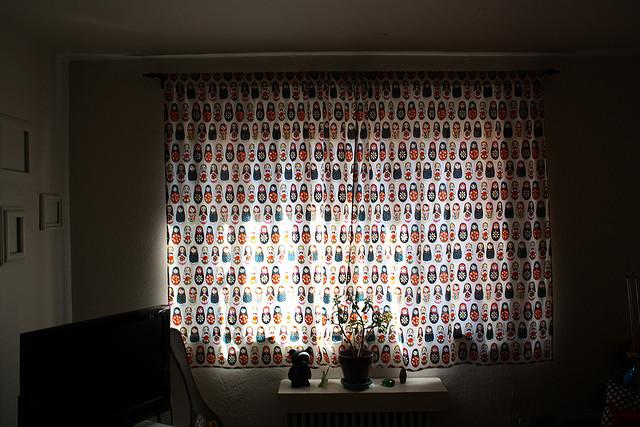What are the walls made of?
Write a very short answer. Plaster. What is hanging in the window?
Write a very short answer. Curtain. Are there curtains on the window?
Answer briefly. Yes. What is covering the window?
Keep it brief. Curtain. Is there anything on the desk?
Write a very short answer. Yes. Is it daytime?
Give a very brief answer. Yes. 